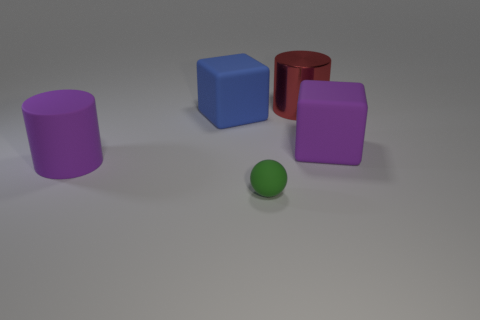Add 3 large red metal cylinders. How many objects exist? 8 Subtract all cylinders. How many objects are left? 3 Subtract 1 green spheres. How many objects are left? 4 Subtract 2 cylinders. How many cylinders are left? 0 Subtract all blue cubes. Subtract all gray cylinders. How many cubes are left? 1 Subtract all metallic cylinders. Subtract all tiny brown cubes. How many objects are left? 4 Add 1 shiny cylinders. How many shiny cylinders are left? 2 Add 1 tiny objects. How many tiny objects exist? 2 Subtract all red cylinders. How many cylinders are left? 1 